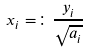Convert formula to latex. <formula><loc_0><loc_0><loc_500><loc_500>x _ { i } = \colon \frac { y _ { i } } { \sqrt { a _ { i } } }</formula> 